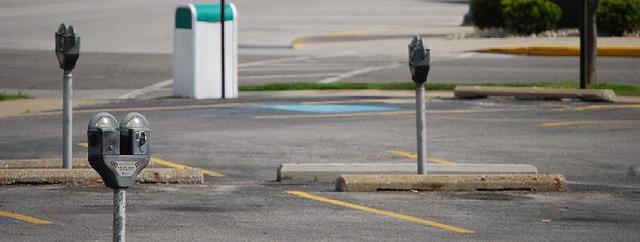How many parking meters do you see?
Answer briefly. 3. What color is the parking meter?
Short answer required. Gray. How many parking meters are there?
Give a very brief answer. 3. What color are the lines in the parking lot?
Be succinct. Yellow. Where do you park your car?
Keep it brief. At meter. 